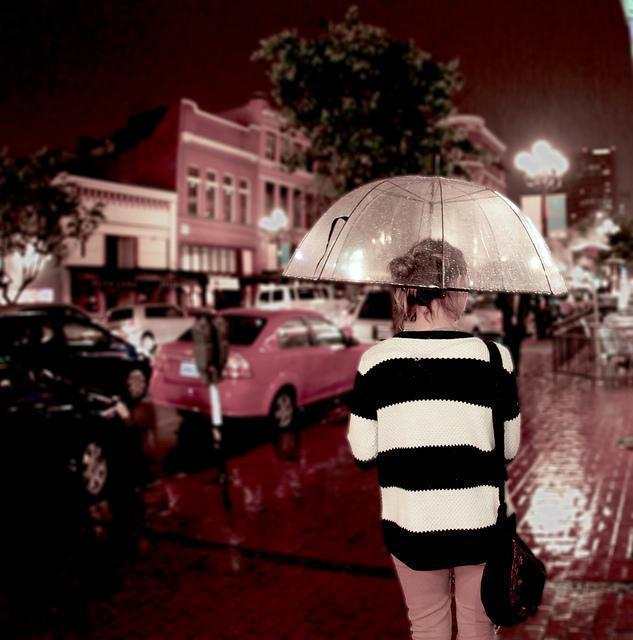Why is the woman using an umbrella?
Choose the right answer and clarify with the format: 'Answer: answer
Rationale: rationale.'
Options: Prevent heat, prevent sunburn, snow, rain. Answer: rain.
Rationale: Umbrellas are used to keep people either dry or out of the sun.  it is not sunny here. 